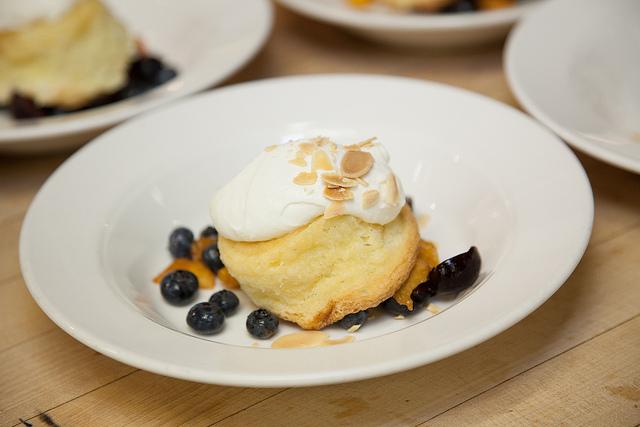Are there vegetables on the plate?
Give a very brief answer. No. What material is the table made from?
Write a very short answer. Wood. What type of cake is this?
Short answer required. Pastry. What color is the bowl?
Concise answer only. White. What are the small blue items?
Be succinct. Blueberries. How many slices are cut from the cake on the left?
Write a very short answer. 0. 